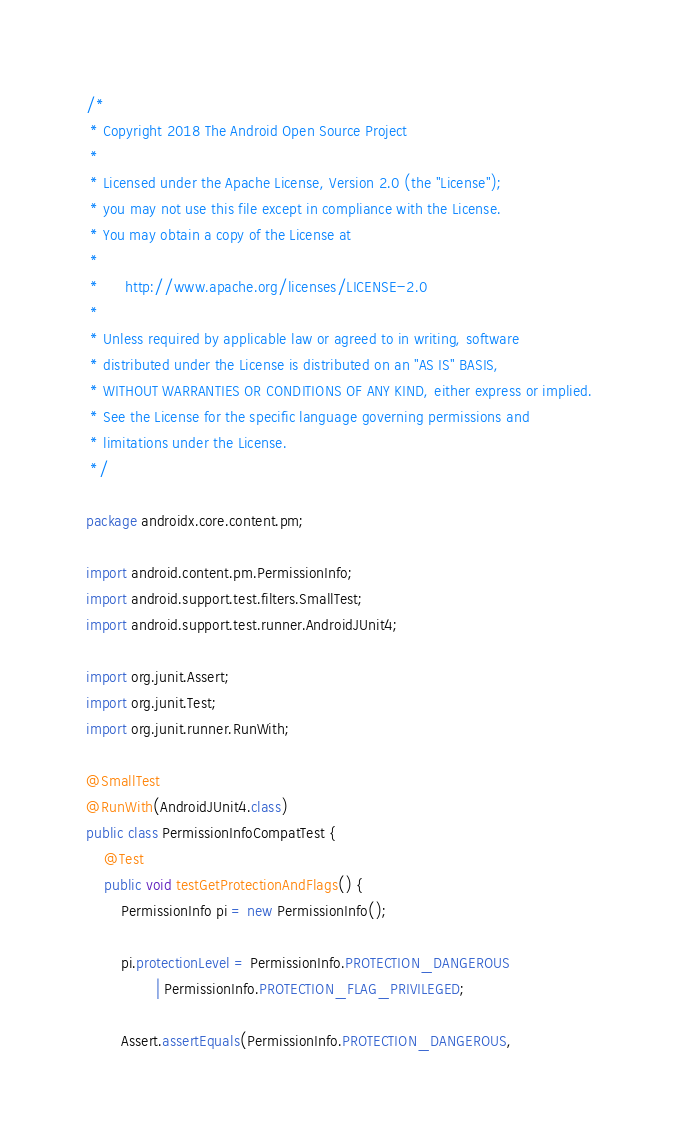<code> <loc_0><loc_0><loc_500><loc_500><_Java_>/*
 * Copyright 2018 The Android Open Source Project
 *
 * Licensed under the Apache License, Version 2.0 (the "License");
 * you may not use this file except in compliance with the License.
 * You may obtain a copy of the License at
 *
 *      http://www.apache.org/licenses/LICENSE-2.0
 *
 * Unless required by applicable law or agreed to in writing, software
 * distributed under the License is distributed on an "AS IS" BASIS,
 * WITHOUT WARRANTIES OR CONDITIONS OF ANY KIND, either express or implied.
 * See the License for the specific language governing permissions and
 * limitations under the License.
 */

package androidx.core.content.pm;

import android.content.pm.PermissionInfo;
import android.support.test.filters.SmallTest;
import android.support.test.runner.AndroidJUnit4;

import org.junit.Assert;
import org.junit.Test;
import org.junit.runner.RunWith;

@SmallTest
@RunWith(AndroidJUnit4.class)
public class PermissionInfoCompatTest {
    @Test
    public void testGetProtectionAndFlags() {
        PermissionInfo pi = new PermissionInfo();

        pi.protectionLevel = PermissionInfo.PROTECTION_DANGEROUS
                | PermissionInfo.PROTECTION_FLAG_PRIVILEGED;

        Assert.assertEquals(PermissionInfo.PROTECTION_DANGEROUS,</code> 